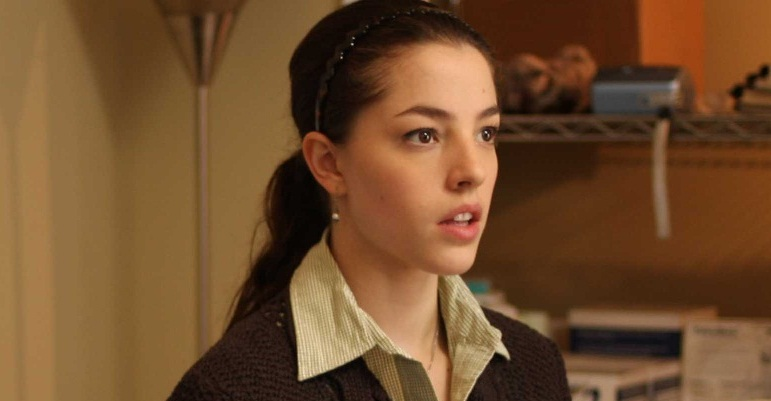Describe the emotional atmosphere and what might be happening just outside the frame. The emotional atmosphere in the image is one of quiet intensity and introspection. The woman appears to be deeply absorbed in her thoughts, with a serious and contemplative expression. A soft, warm light gives a sense of calm and stillness to the scene. Just outside the frame, one might imagine a small, cozy room filled with books and personal mementos, suggesting that the woman could be reflecting on something she has just read or seen. Perhaps she is preparing to make an important decision or reminiscing about a significant memory. The quiet environment lends itself to a solitary moment of reflection and inner dialogue. 